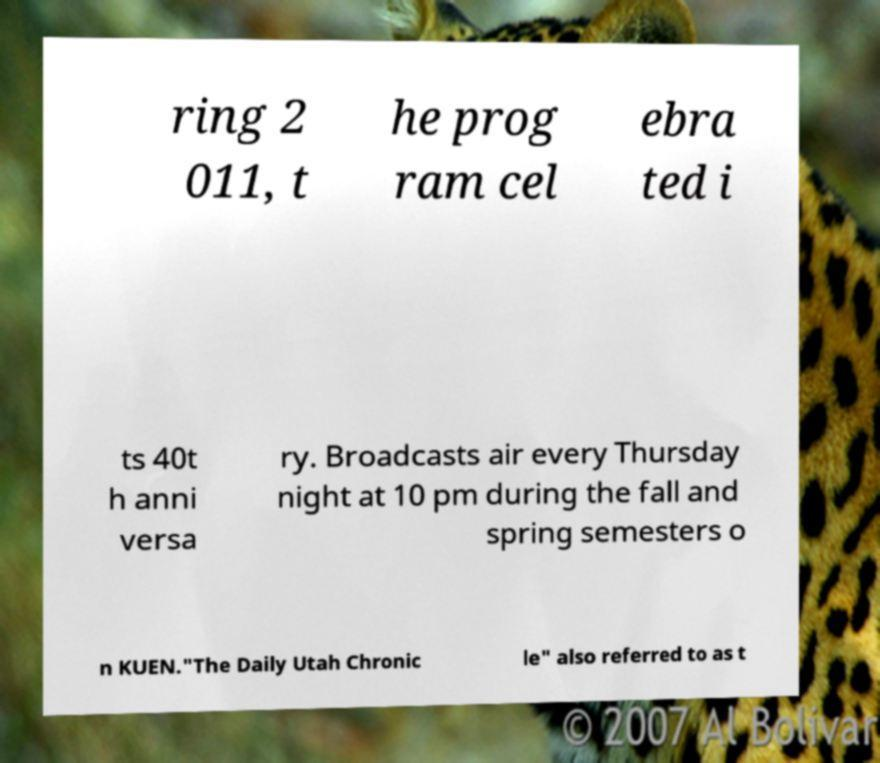Can you accurately transcribe the text from the provided image for me? ring 2 011, t he prog ram cel ebra ted i ts 40t h anni versa ry. Broadcasts air every Thursday night at 10 pm during the fall and spring semesters o n KUEN."The Daily Utah Chronic le" also referred to as t 